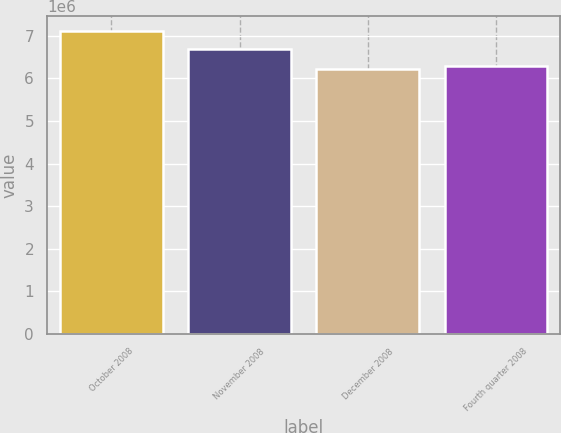Convert chart. <chart><loc_0><loc_0><loc_500><loc_500><bar_chart><fcel>October 2008<fcel>November 2008<fcel>December 2008<fcel>Fourth quarter 2008<nl><fcel>7.1084e+06<fcel>6.6993e+06<fcel>6.2157e+06<fcel>6.30497e+06<nl></chart> 